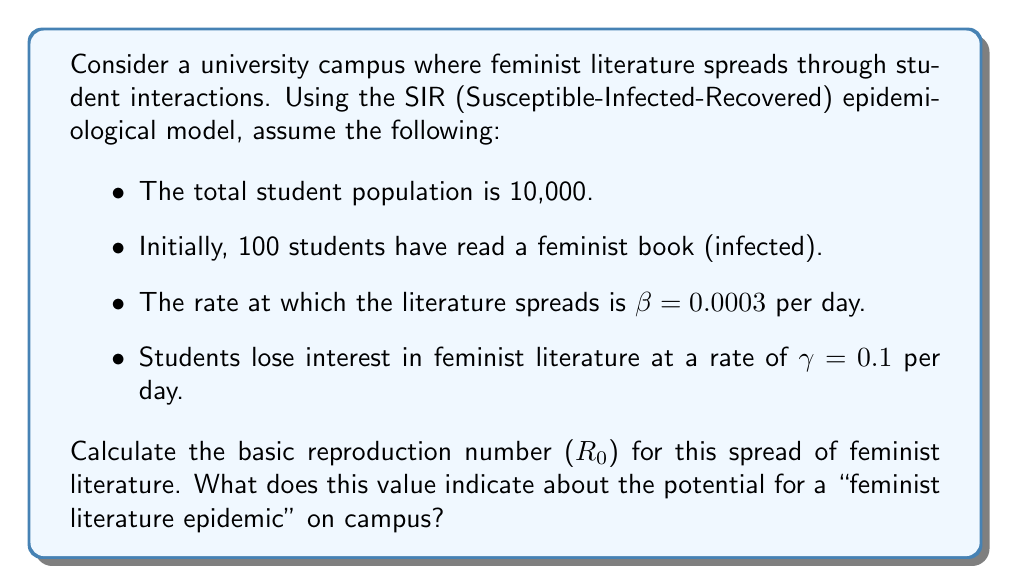Solve this math problem. To solve this problem, we'll follow these steps:

1. Recall the formula for the basic reproduction number ($R_0$) in the SIR model:

   $$R_0 = \frac{\beta N}{\gamma}$$

   Where:
   - $\beta$ is the transmission rate
   - $N$ is the total population
   - $\gamma$ is the recovery rate

2. Substitute the given values:
   - $\beta = 0.0003$ per day
   - $N = 10,000$ students
   - $\gamma = 0.1$ per day

3. Calculate $R_0$:

   $$R_0 = \frac{0.0003 \times 10,000}{0.1} = \frac{3}{1} = 3$$

4. Interpret the result:
   - If $R_0 > 1$, the "infection" (in this case, interest in feminist literature) will spread exponentially.
   - If $R_0 < 1$, the "infection" will die out.
   - Here, $R_0 = 3 > 1$, indicating that each student who reads feminist literature will, on average, inspire 3 other students to read it before losing interest themselves.

This value suggests that there is potential for a "feminist literature epidemic" on campus, as the interest is likely to spread and grow over time.
Answer: $R_0 = 3$; indicates potential for exponential spread of feminist literature on campus. 